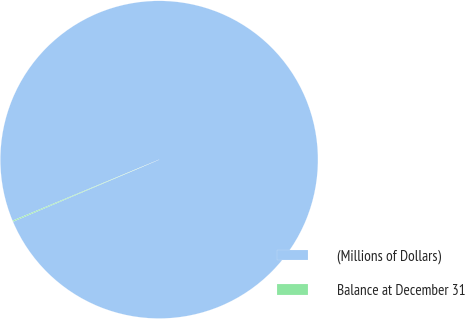Convert chart to OTSL. <chart><loc_0><loc_0><loc_500><loc_500><pie_chart><fcel>(Millions of Dollars)<fcel>Balance at December 31<nl><fcel>99.9%<fcel>0.1%<nl></chart> 